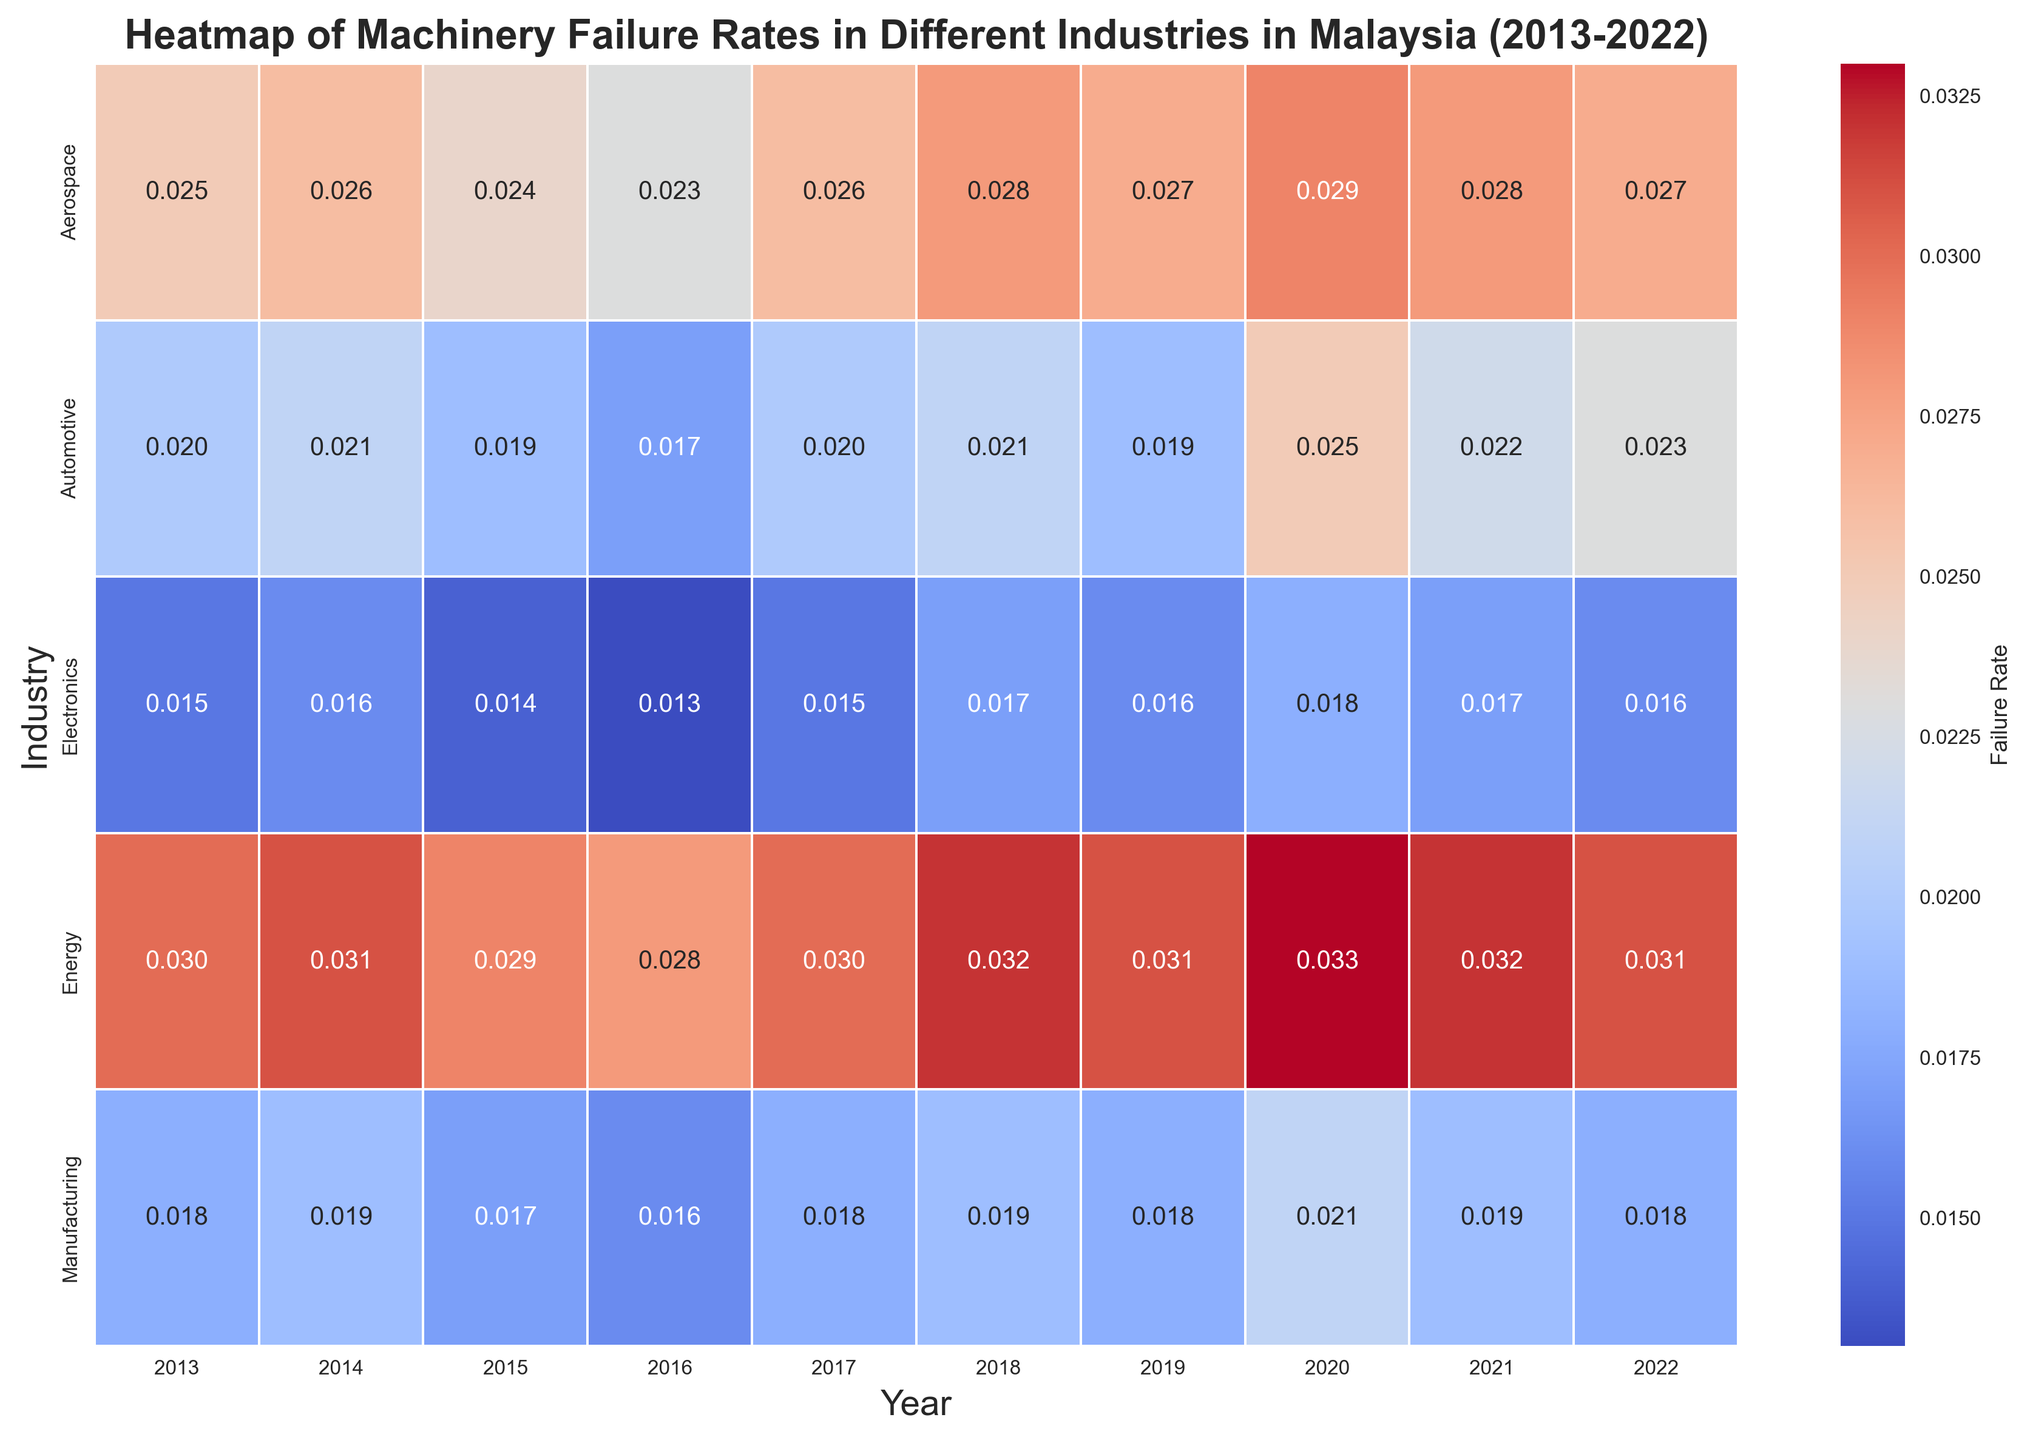Which industry had the highest failure rate in 2020? To find the industry with the highest failure rate in 2020, locate the column for the year 2020. Compare the failure rates in this column for each industry. The Energy industry has the highest value with a failure rate of 0.033.
Answer: Energy Which two years saw an increase in failure rate for the Automotive industry? For the Automotive industry, analyze the failure rates for each year. The failure rate increases from 2016 to 2017 (0.017 to 0.02) and from 2019 to 2020 (0.019 to 0.025).
Answer: 2017, 2020 What is the average failure rate of the Manufacturing industry over the 10 years? First, sum the failure rates for the Manufacturing industry over the years: 0.018 + 0.019 + 0.017 + 0.016 + 0.018 + 0.019 + 0.018 + 0.021 + 0.019 + 0.018 = 0.183. Then, divide by the number of years (10). The average failure rate is 0.183/10 = 0.0183.
Answer: 0.0183 Compare the trend of failure rates for Electronics and Aerospace industries. Which industry had a more consistent failure rate trend? Examine the pattern for annual changes in failure rates for both industries. The Electronics industry has smaller and more consistent variations between years (e.g., between 0.013 and 0.018). The Aerospace industry has larger variations (e.g., between 0.023 and 0.029). Therefore, the Electronics industry had a more consistent failure rate trend.
Answer: Electronics Which year had the lowest failure rate across all industries? Check all the failure rates in each year and identify the minimum value. The lowest failure rate is in 2016 for the Electronics industry with a rate of 0.013.
Answer: 2016 How did the failure rate for the Energy industry change from 2015 to 2022? Evaluate the failure rates for the Energy industry from 2015 to 2022: 0.029 in 2015, 0.028 in 2016, 0.030 in 2017, 0.032 in 2018, 0.031 in 2019, 0.033 in 2020, 0.032 in 2021, and 0.031 in 2022. The rate fluctuated but generally increased reaching a peak in 2020 before slightly decreasing.
Answer: Fluctuated, peaked in 2020 Which industry had an increasing trend in failure rates from 2019 to 2022? Check the failure rates for each industry from 2019 to 2022. Only the Aerospace industry consistently increased its failure rates from 0.027 in 2019 to 0.028 in 2021, before dropping slightly to 0.027 in 2022. Another example is Energy, which also shows an increasing trend from 2019 (0.031) to 2020 (0.033) and then a slight decrease in subsequent years. The answer can be either Aerospace or Energy.
Answer: Aerospace, Energy 